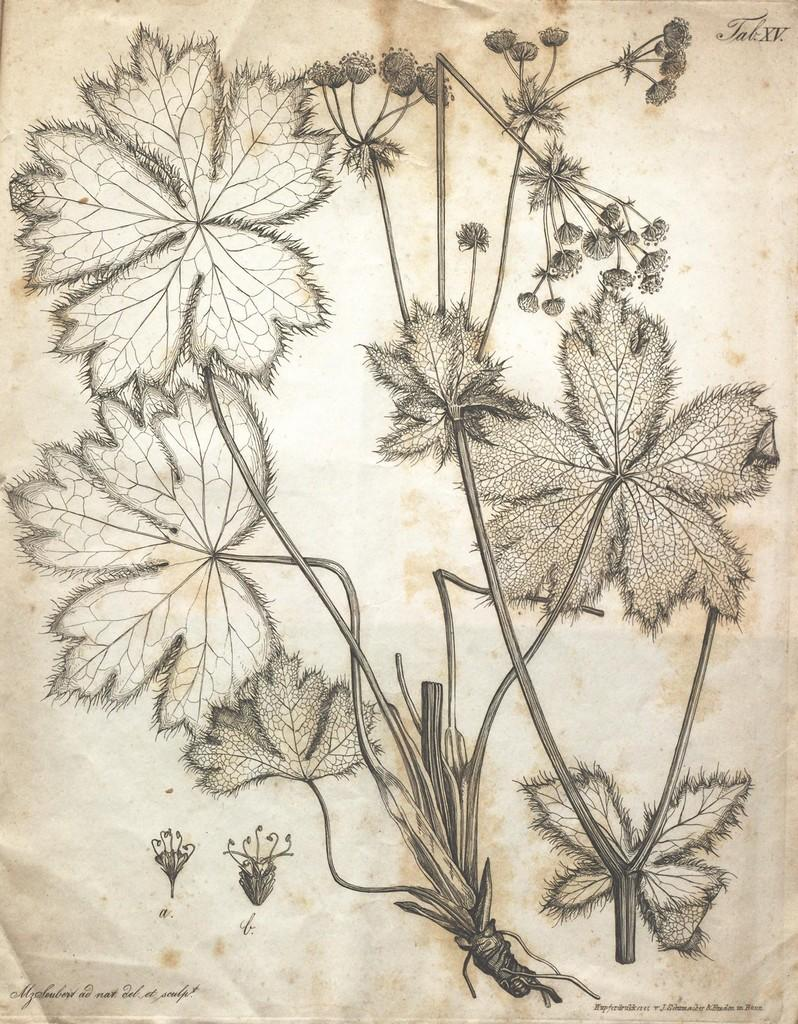What is the image printed on? The image is on a paper. What is depicted in the image on the paper? There is a design of a plant with flowers on the paper. Is there any text accompanying the image on the paper? Yes, there is text at the bottom of the paper. What type of reaction does the plant have to low temperatures in the image? There is no indication of the plant's reaction to low temperatures in the image, as it is a static design. 